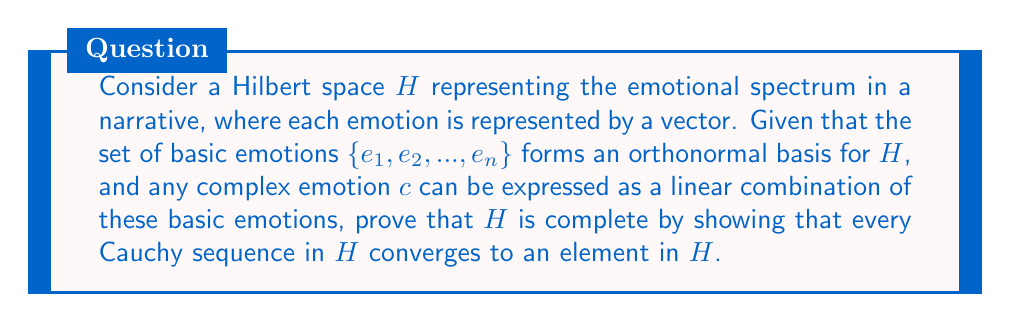What is the answer to this math problem? To prove the completeness of the Hilbert space $H$, we need to show that every Cauchy sequence in $H$ converges to an element in $H$. This proof will demonstrate that the emotional spectrum represented by $H$ is comprehensive and can capture all possible emotional nuances in a narrative.

Step 1: Consider a Cauchy sequence $\{x_n\}$ in $H$.

Step 2: Since $\{e_1, e_2, ..., e_n\}$ forms an orthonormal basis for $H$, we can express each $x_n$ as:

$$x_n = \sum_{i=1}^{\infty} \alpha_{n,i} e_i$$

where $\alpha_{n,i} = \langle x_n, e_i \rangle$ are the Fourier coefficients.

Step 3: For any $\epsilon > 0$, there exists an $N$ such that for all $m, k > N$:

$$\|x_m - x_k\| < \epsilon$$

Step 4: Using the Pythagorean theorem in $H$, we have:

$$\|x_m - x_k\|^2 = \sum_{i=1}^{\infty} |\alpha_{m,i} - \alpha_{k,i}|^2 < \epsilon^2$$

Step 5: This implies that for each $i$, $\{\alpha_{n,i}\}$ is a Cauchy sequence in $\mathbb{C}$.

Step 6: Since $\mathbb{C}$ is complete, each $\{\alpha_{n,i}\}$ converges to some $\alpha_i \in \mathbb{C}$.

Step 7: Define $x = \sum_{i=1}^{\infty} \alpha_i e_i$.

Step 8: We need to show that $x_n \to x$ in $H$. For any $\epsilon > 0$, choose $N$ such that for all $m, k > N$:

$$\sum_{i=1}^{\infty} |\alpha_{m,i} - \alpha_{k,i}|^2 < \frac{\epsilon^2}{4}$$

Step 9: Let $n \to \infty$, we get:

$$\sum_{i=1}^{\infty} |\alpha_i - \alpha_{k,i}|^2 \leq \frac{\epsilon^2}{4}$$

Step 10: Therefore, for $k > N$:

$$\|x - x_k\|^2 = \sum_{i=1}^{\infty} |\alpha_i - \alpha_{k,i}|^2 < \frac{\epsilon^2}{4} < \epsilon^2$$

This proves that $x_n \to x$ in $H$, and thus $H$ is complete.
Answer: The Hilbert space $H$ representing the emotional spectrum in a narrative is complete, as every Cauchy sequence in $H$ converges to an element in $H$. 